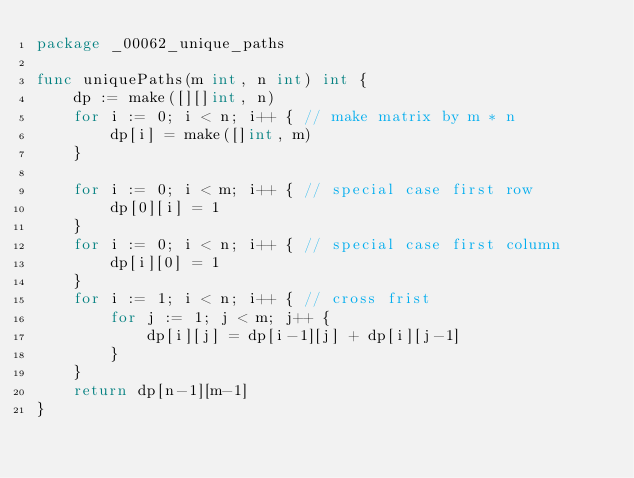Convert code to text. <code><loc_0><loc_0><loc_500><loc_500><_Go_>package _00062_unique_paths

func uniquePaths(m int, n int) int {
	dp := make([][]int, n)
	for i := 0; i < n; i++ { // make matrix by m * n
		dp[i] = make([]int, m)
	}

	for i := 0; i < m; i++ { // special case first row
		dp[0][i] = 1
	}
	for i := 0; i < n; i++ { // special case first column
		dp[i][0] = 1
	}
	for i := 1; i < n; i++ { // cross frist
		for j := 1; j < m; j++ {
			dp[i][j] = dp[i-1][j] + dp[i][j-1]
		}
	}
	return dp[n-1][m-1]
}
</code> 